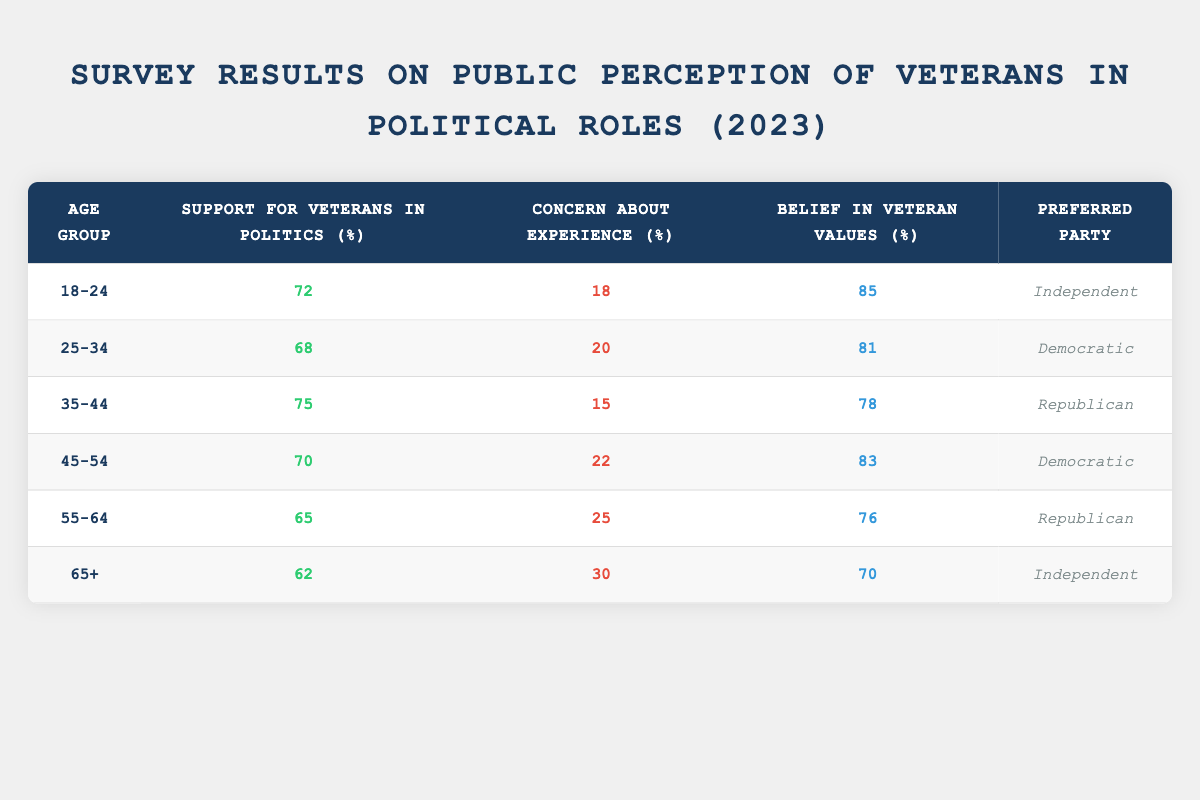What percentage of respondents aged 18-24 support veterans in politics? From the table, the support for veterans in politics in the 18-24 age group is listed as 72%.
Answer: 72% Which age group shows the highest belief in veteran values? The highest belief in veteran values is found in the 18-24 age group at 85%.
Answer: 18-24 What is the average concern about experience across all age groups? To find the average concern about experience, we sum the concerns from all age groups: (18 + 20 + 15 + 22 + 25 + 30) = 130. Then, we divide by the number of age groups (6): 130/6 = approximately 21.67%.
Answer: 21.67% Is there a correlation between age group and support for veterans in politics? Analyzing the data, support generally decreases as age increases. This trend suggests an inverse relationship.
Answer: Yes What percentage of 55-64 year-olds are concerned about veterans' experience? The percentage of 55-64 year-olds who are concerned about experience is listed as 25%.
Answer: 25% Which age group has the least support for veterans in politics? The age group with the least support is 65+, with a support level of 62%.
Answer: 65+ What is the difference in belief in veteran values between the 25-34 and 45-54 age groups? For 25-34, the belief in veteran values is 81% and for 45-54, it is 83%. The difference is 83 - 81 = 2%.
Answer: 2% Which political party is preferred by the 35-44 age group? According to the table, the preferred party for the 35-44 age group is Republican.
Answer: Republican What is the median support for veterans in politics across all age groups? The support percentages are 72, 68, 75, 70, 65, and 62. Arranging them in order gives 62, 65, 68, 70, 72, 75. The median, being the average of the two middle values (68 and 70), is (68 + 70)/2 = 69%.
Answer: 69% Which group has higher concern about experience: 25-34 or 55-64? The concern about experience for 25-34 is 20% and for 55-64 is 25%. Since 25% is greater, the 55-64 age group has higher concern.
Answer: 55-64 What is the total support for veterans in politics from respondents aged 45-54 and above? The support values for the 45-54 age group is 70% and for the 55-64 age group is 65%, and for 65+ it is 62%. Thus, the total support is 70 + 65 + 62 = 197%.
Answer: 197% Which age group shows the greatest increase in concern about experience when compared to the youngest group (18-24)? The concern for the 18-24 age group is 18%, and for the 25-34 age group it is 20%. The greatest increase occurs in the 65+ age group, which has a concern rate of 30%, indicating an increase of 12%.
Answer: 65+ What party do the majority of respondents aged 55-64 prefer? The preferred party for the 55-64 age group is Republican, as listed in the table.
Answer: Republican 